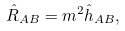Convert formula to latex. <formula><loc_0><loc_0><loc_500><loc_500>\hat { R } _ { A B } = m ^ { 2 } \hat { h } _ { A B } ,</formula> 